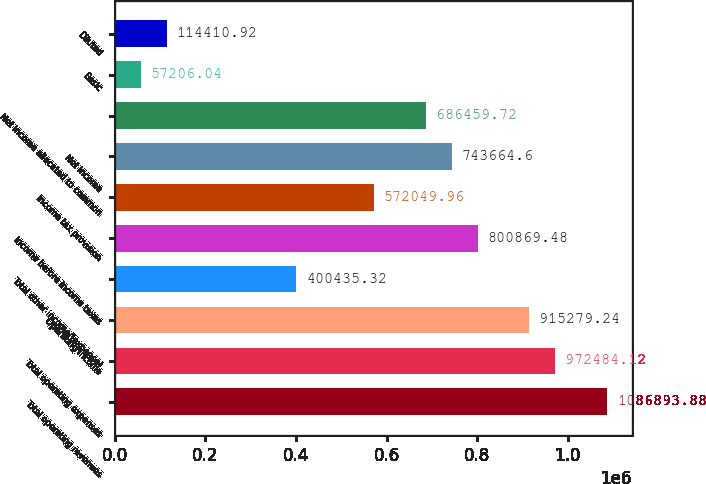<chart> <loc_0><loc_0><loc_500><loc_500><bar_chart><fcel>Total operating revenues<fcel>Total operating expenses<fcel>Operating income<fcel>Total other income/(expense)<fcel>Income before income taxes<fcel>Income tax provision<fcel>Net income<fcel>Net income allocated to common<fcel>Basic<fcel>Diluted<nl><fcel>1.08689e+06<fcel>972484<fcel>915279<fcel>400435<fcel>800869<fcel>572050<fcel>743665<fcel>686460<fcel>57206<fcel>114411<nl></chart> 